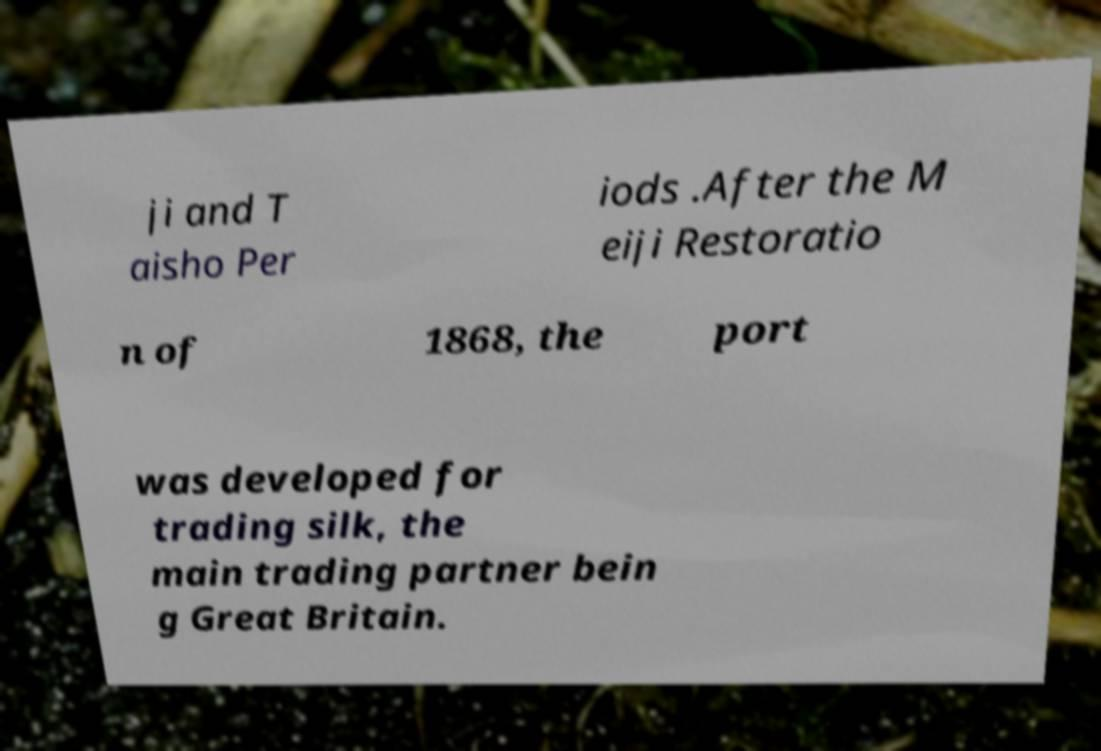Could you extract and type out the text from this image? ji and T aisho Per iods .After the M eiji Restoratio n of 1868, the port was developed for trading silk, the main trading partner bein g Great Britain. 